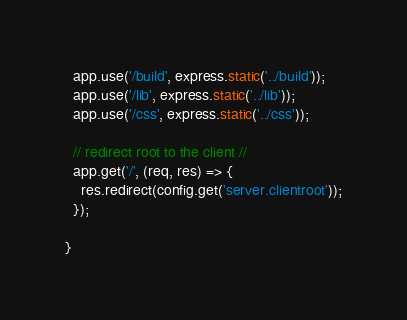Convert code to text. <code><loc_0><loc_0><loc_500><loc_500><_JavaScript_>  app.use('/build', express.static('../build'));
  app.use('/lib', express.static('../lib'));
  app.use('/css', express.static('../css'));

  // redirect root to the client //
  app.get('/', (req, res) => {
    res.redirect(config.get('server.clientroot'));
  });

}

</code> 